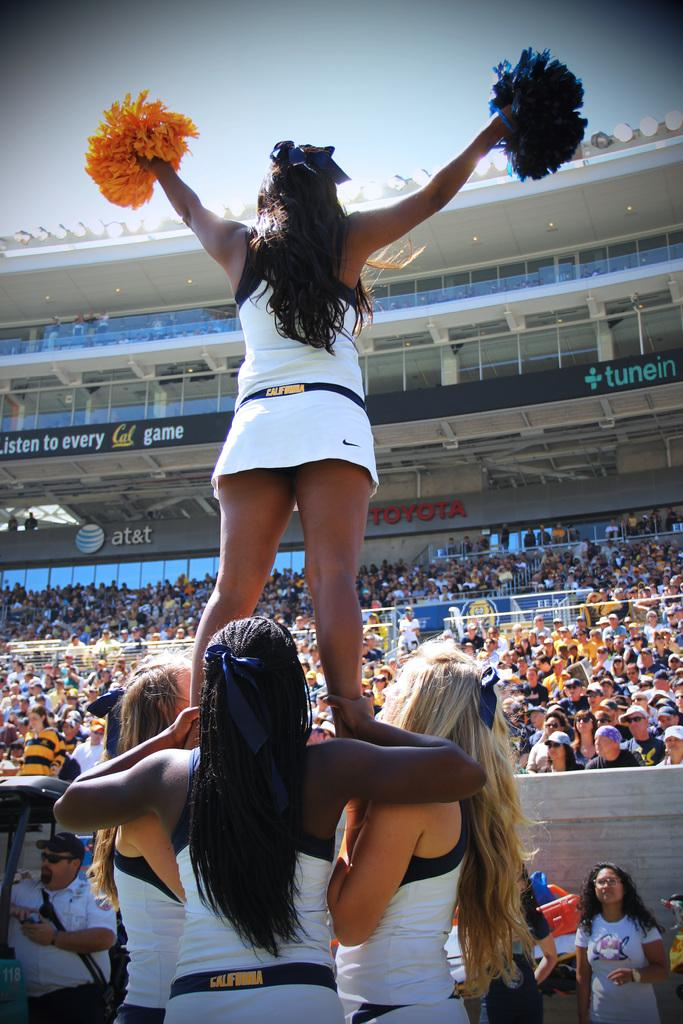<image>
Create a compact narrative representing the image presented. Cheerleaders perform for a crowd while facing walls featuring ads for AT&T, Toyota and others. 